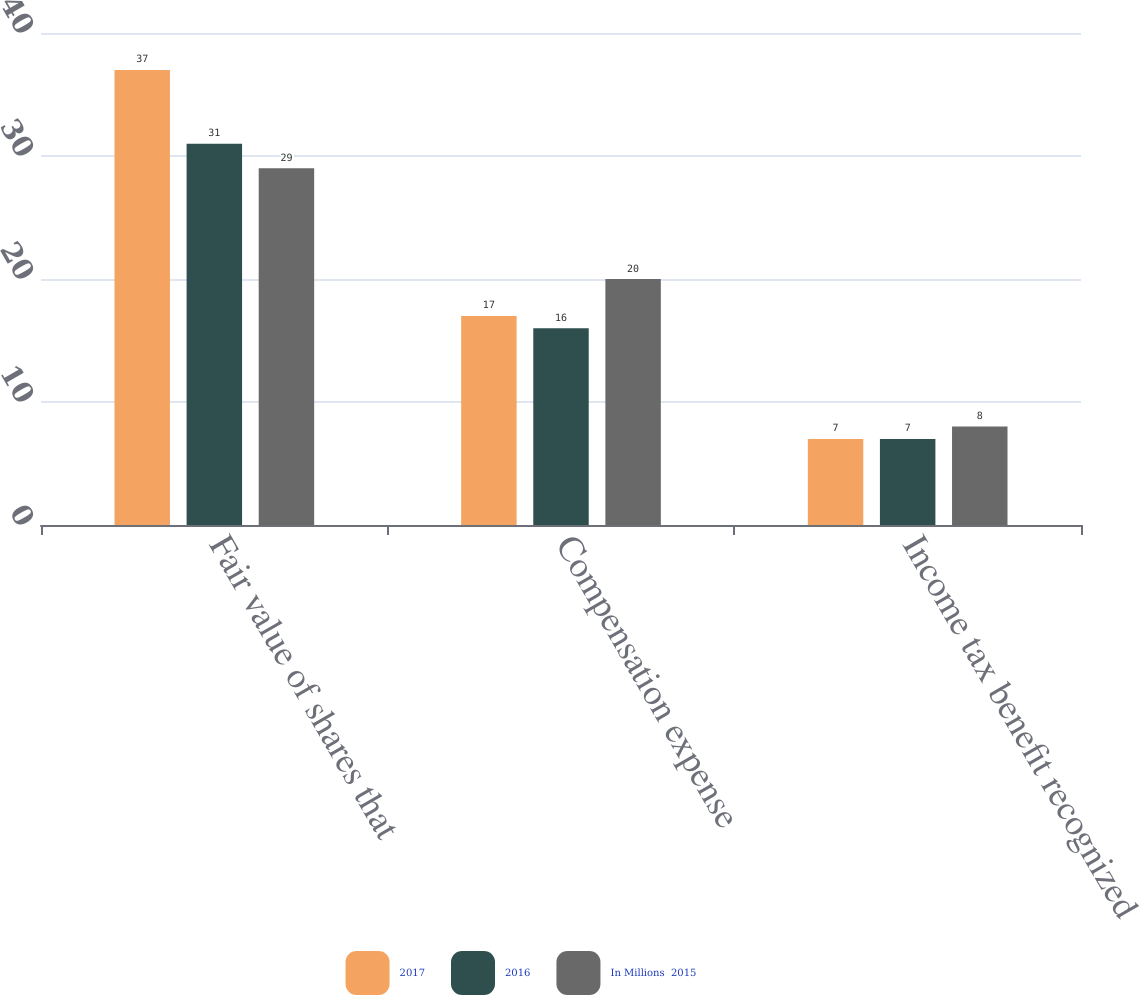Convert chart. <chart><loc_0><loc_0><loc_500><loc_500><stacked_bar_chart><ecel><fcel>Fair value of shares that<fcel>Compensation expense<fcel>Income tax benefit recognized<nl><fcel>2017<fcel>37<fcel>17<fcel>7<nl><fcel>2016<fcel>31<fcel>16<fcel>7<nl><fcel>In Millions  2015<fcel>29<fcel>20<fcel>8<nl></chart> 